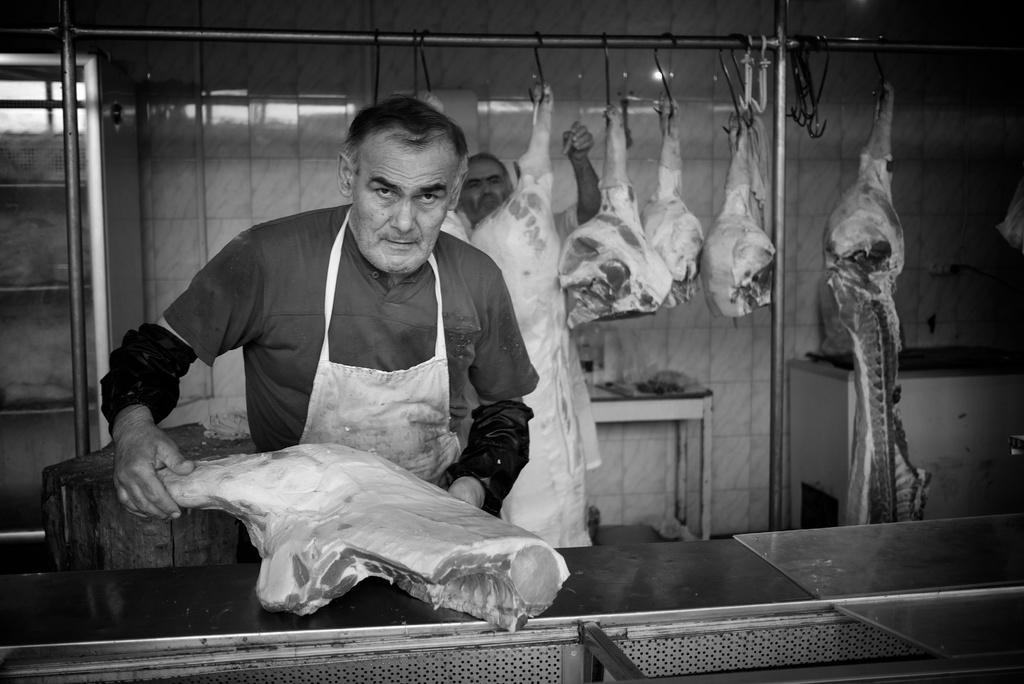In one or two sentences, can you explain what this image depicts? In the picture I can see a man on the left side and he is holding the goat meat in his hands. I can see the goat meat on the hook. I can see the stainless steel pole at the top of the picture. I can see the glass display container on the left side. I can see the wooden log on the left side. I can see the wash basin on the right side. 